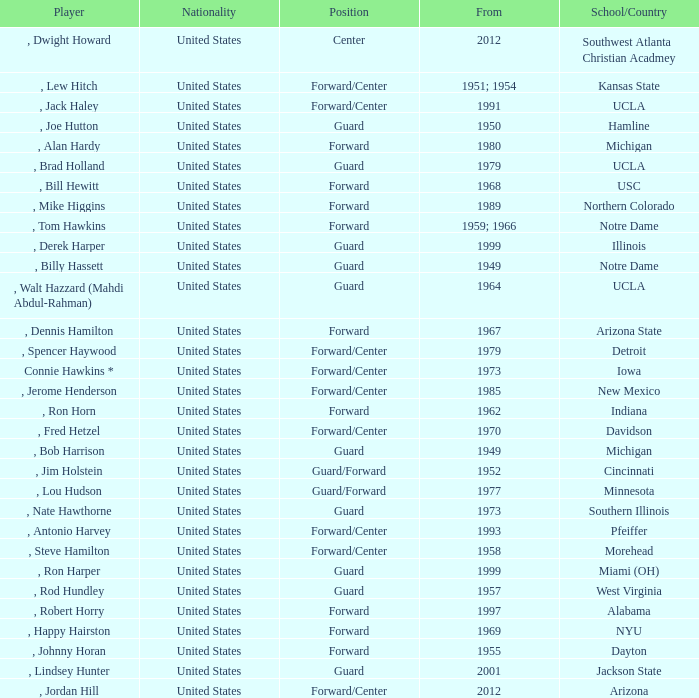Which school has the player that started in 1958? Morehead. 